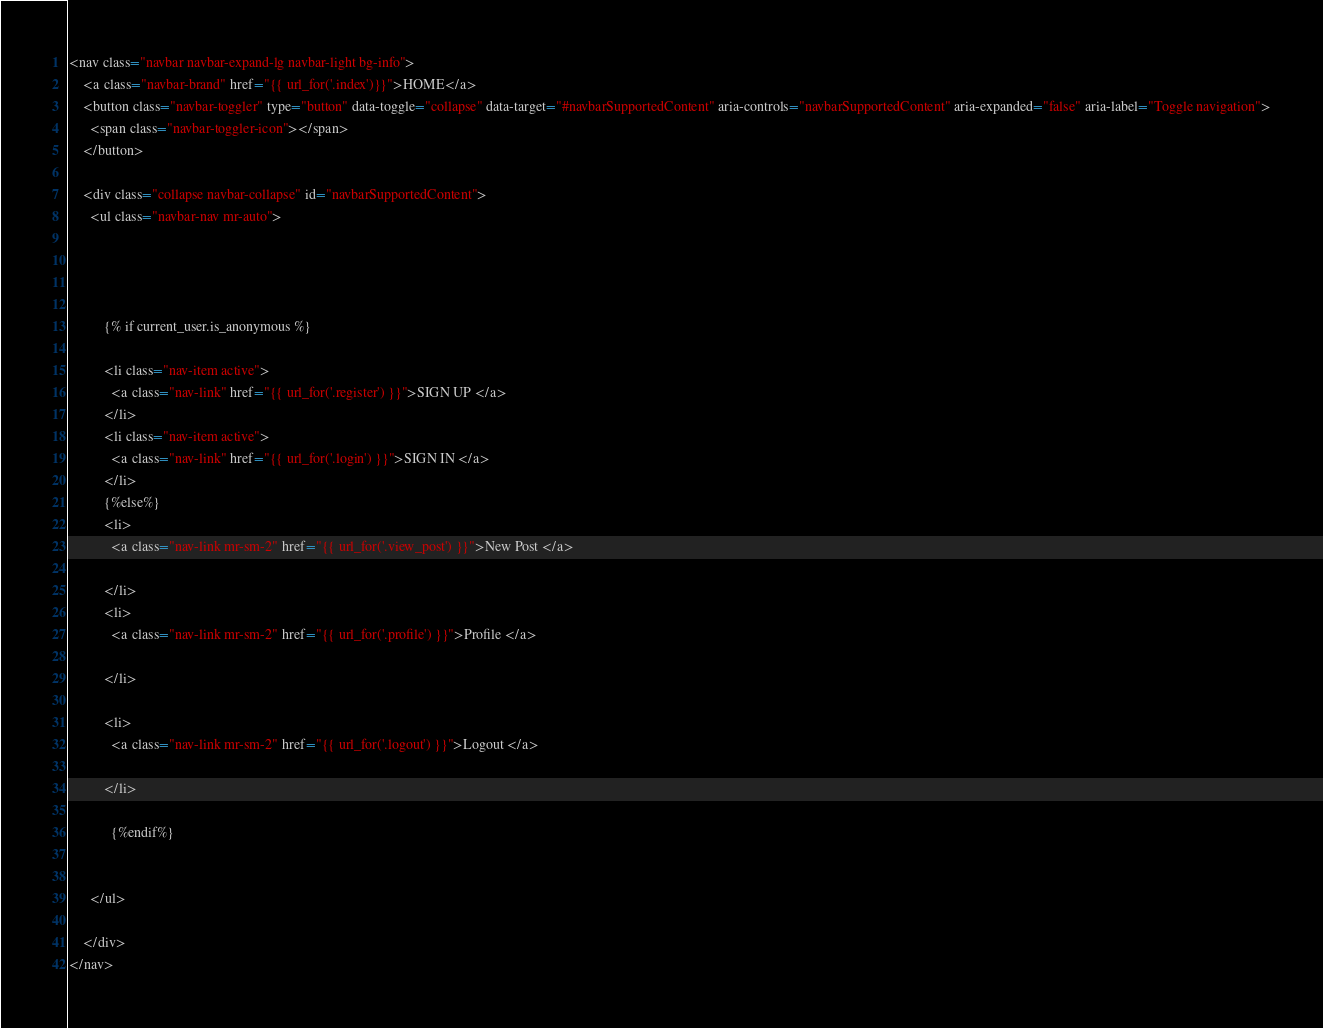Convert code to text. <code><loc_0><loc_0><loc_500><loc_500><_HTML_><nav class="navbar navbar-expand-lg navbar-light bg-info">
    <a class="navbar-brand" href="{{ url_for('.index')}}">HOME</a>
    <button class="navbar-toggler" type="button" data-toggle="collapse" data-target="#navbarSupportedContent" aria-controls="navbarSupportedContent" aria-expanded="false" aria-label="Toggle navigation">
      <span class="navbar-toggler-icon"></span>
    </button>
  
    <div class="collapse navbar-collapse" id="navbarSupportedContent">
      <ul class="navbar-nav mr-auto">
       
        

      
          {% if current_user.is_anonymous %}
          
          <li class="nav-item active">
            <a class="nav-link" href="{{ url_for('.register') }}">SIGN UP </a>
          </li>
          <li class="nav-item active">
            <a class="nav-link" href="{{ url_for('.login') }}">SIGN IN </a>
          </li>
          {%else%}
          <li>
            <a class="nav-link mr-sm-2" href="{{ url_for('.view_post') }}">New Post </a>

          </li>
          <li>
            <a class="nav-link mr-sm-2" href="{{ url_for('.profile') }}">Profile </a>

          </li>
         
          <li>
            <a class="nav-link mr-sm-2" href="{{ url_for('.logout') }}">Logout </a>

          </li>
           
            {%endif%}

        
      </ul>
     
    </div>
</nav></code> 